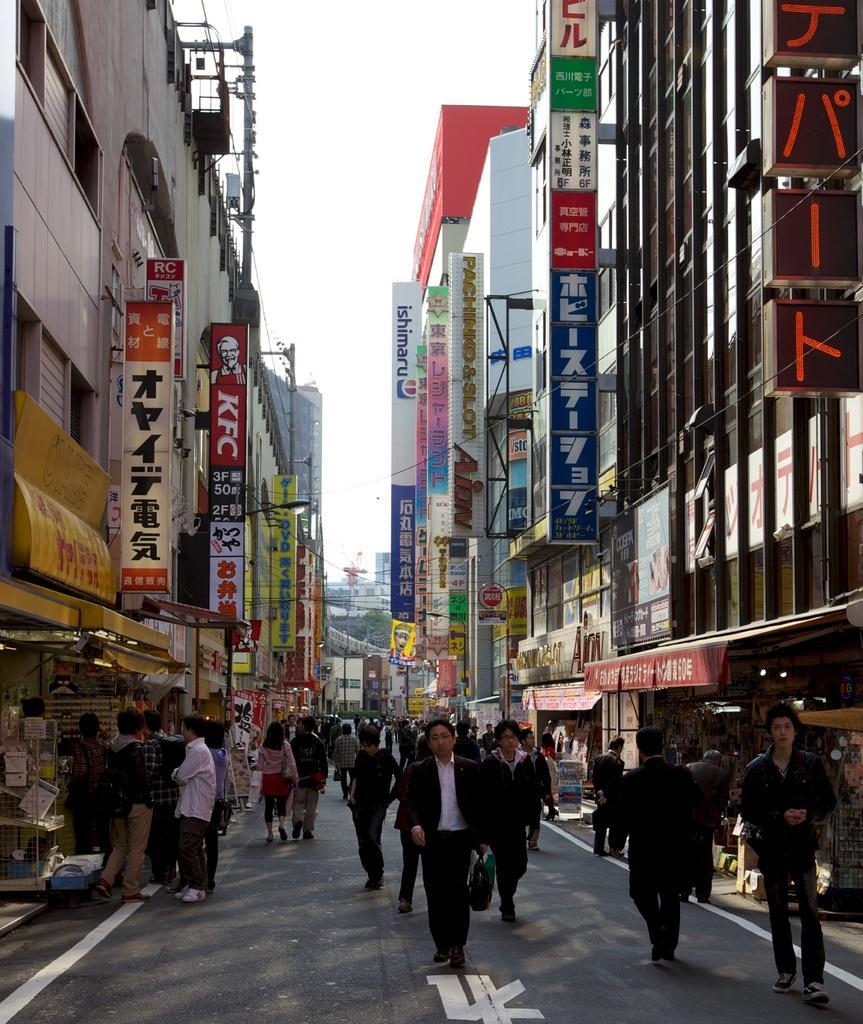In one or two sentences, can you explain what this image depicts? In this image I can see group of people some are standing and some are walking, left and right I can see few banners attached to the building, background I can see few buildings in multi color, trees in green color and sky in white color. 